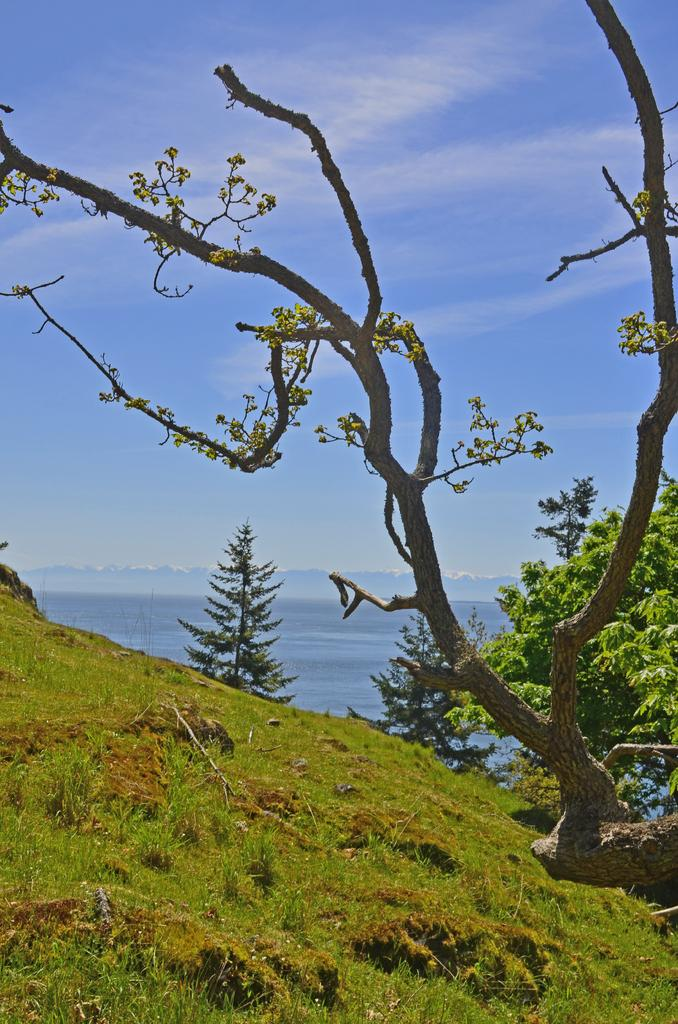What type of vegetation is present on the hill in the image? There is grass on the hill in the image. What can be seen to the right of the hill in the image? There are trees to the right in the image. What is visible in the distance behind the hill in the image? There is water visible in the background of the image. What is visible at the top of the image? The sky is visible at the top of the image. Who is the owner of the property in the image? There is no information about property ownership in the image. How does the balance of the hill affect the trees in the image? The image does not provide any information about the balance of the hill or its impact on the trees. 